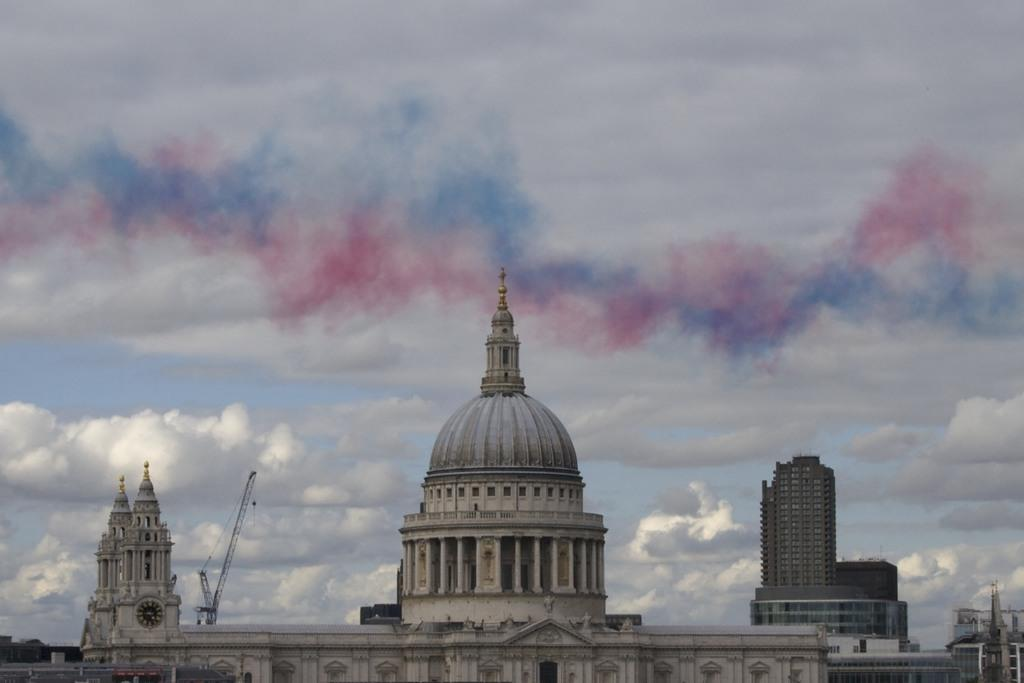What type of structures are visible in the image? There are buildings in the image. Can you describe any specific features of the buildings? There is a clock on the tower of a building. What type of machinery can be seen in the image? There is a crane in the image. How would you describe the sky in the image? The sky is blue and cloudy. What type of attraction is the thread performing in the image? There is no thread or attraction present in the image. Who is the achiever in the image? There is no individual or achiever mentioned or depicted in the image. 